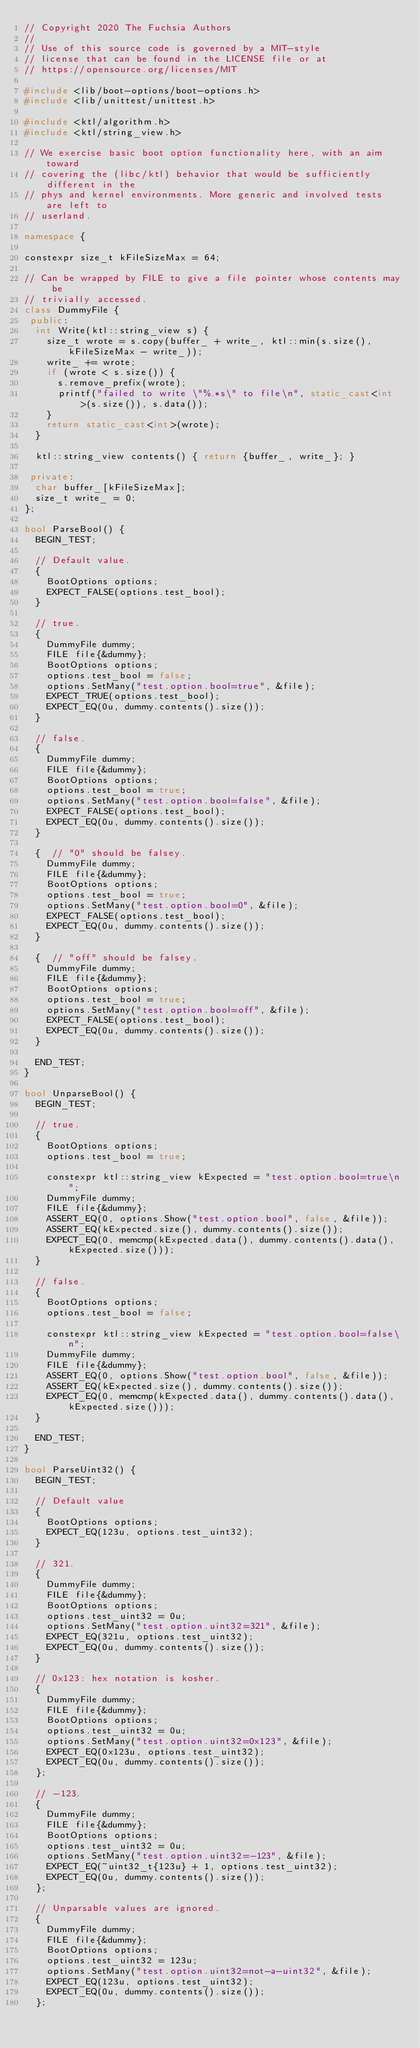Convert code to text. <code><loc_0><loc_0><loc_500><loc_500><_C++_>// Copyright 2020 The Fuchsia Authors
//
// Use of this source code is governed by a MIT-style
// license that can be found in the LICENSE file or at
// https://opensource.org/licenses/MIT

#include <lib/boot-options/boot-options.h>
#include <lib/unittest/unittest.h>

#include <ktl/algorithm.h>
#include <ktl/string_view.h>

// We exercise basic boot option functionality here, with an aim toward
// covering the (libc/ktl) behavior that would be sufficiently different in the
// phys and kernel environments. More generic and involved tests are left to
// userland.

namespace {

constexpr size_t kFileSizeMax = 64;

// Can be wrapped by FILE to give a file pointer whose contents may be
// trivially accessed.
class DummyFile {
 public:
  int Write(ktl::string_view s) {
    size_t wrote = s.copy(buffer_ + write_, ktl::min(s.size(), kFileSizeMax - write_));
    write_ += wrote;
    if (wrote < s.size()) {
      s.remove_prefix(wrote);
      printf("failed to write \"%.*s\" to file\n", static_cast<int>(s.size()), s.data());
    }
    return static_cast<int>(wrote);
  }

  ktl::string_view contents() { return {buffer_, write_}; }

 private:
  char buffer_[kFileSizeMax];
  size_t write_ = 0;
};

bool ParseBool() {
  BEGIN_TEST;

  // Default value.
  {
    BootOptions options;
    EXPECT_FALSE(options.test_bool);
  }

  // true.
  {
    DummyFile dummy;
    FILE file{&dummy};
    BootOptions options;
    options.test_bool = false;
    options.SetMany("test.option.bool=true", &file);
    EXPECT_TRUE(options.test_bool);
    EXPECT_EQ(0u, dummy.contents().size());
  }

  // false.
  {
    DummyFile dummy;
    FILE file{&dummy};
    BootOptions options;
    options.test_bool = true;
    options.SetMany("test.option.bool=false", &file);
    EXPECT_FALSE(options.test_bool);
    EXPECT_EQ(0u, dummy.contents().size());
  }

  {  // "0" should be falsey.
    DummyFile dummy;
    FILE file{&dummy};
    BootOptions options;
    options.test_bool = true;
    options.SetMany("test.option.bool=0", &file);
    EXPECT_FALSE(options.test_bool);
    EXPECT_EQ(0u, dummy.contents().size());
  }

  {  // "off" should be falsey.
    DummyFile dummy;
    FILE file{&dummy};
    BootOptions options;
    options.test_bool = true;
    options.SetMany("test.option.bool=off", &file);
    EXPECT_FALSE(options.test_bool);
    EXPECT_EQ(0u, dummy.contents().size());
  }

  END_TEST;
}

bool UnparseBool() {
  BEGIN_TEST;

  // true.
  {
    BootOptions options;
    options.test_bool = true;

    constexpr ktl::string_view kExpected = "test.option.bool=true\n";
    DummyFile dummy;
    FILE file{&dummy};
    ASSERT_EQ(0, options.Show("test.option.bool", false, &file));
    ASSERT_EQ(kExpected.size(), dummy.contents().size());
    EXPECT_EQ(0, memcmp(kExpected.data(), dummy.contents().data(), kExpected.size()));
  }

  // false.
  {
    BootOptions options;
    options.test_bool = false;

    constexpr ktl::string_view kExpected = "test.option.bool=false\n";
    DummyFile dummy;
    FILE file{&dummy};
    ASSERT_EQ(0, options.Show("test.option.bool", false, &file));
    ASSERT_EQ(kExpected.size(), dummy.contents().size());
    EXPECT_EQ(0, memcmp(kExpected.data(), dummy.contents().data(), kExpected.size()));
  }

  END_TEST;
}

bool ParseUint32() {
  BEGIN_TEST;

  // Default value
  {
    BootOptions options;
    EXPECT_EQ(123u, options.test_uint32);
  }

  // 321.
  {
    DummyFile dummy;
    FILE file{&dummy};
    BootOptions options;
    options.test_uint32 = 0u;
    options.SetMany("test.option.uint32=321", &file);
    EXPECT_EQ(321u, options.test_uint32);
    EXPECT_EQ(0u, dummy.contents().size());
  }

  // 0x123: hex notation is kosher.
  {
    DummyFile dummy;
    FILE file{&dummy};
    BootOptions options;
    options.test_uint32 = 0u;
    options.SetMany("test.option.uint32=0x123", &file);
    EXPECT_EQ(0x123u, options.test_uint32);
    EXPECT_EQ(0u, dummy.contents().size());
  };

  // -123.
  {
    DummyFile dummy;
    FILE file{&dummy};
    BootOptions options;
    options.test_uint32 = 0u;
    options.SetMany("test.option.uint32=-123", &file);
    EXPECT_EQ(~uint32_t{123u} + 1, options.test_uint32);
    EXPECT_EQ(0u, dummy.contents().size());
  };

  // Unparsable values are ignored.
  {
    DummyFile dummy;
    FILE file{&dummy};
    BootOptions options;
    options.test_uint32 = 123u;
    options.SetMany("test.option.uint32=not-a-uint32", &file);
    EXPECT_EQ(123u, options.test_uint32);
    EXPECT_EQ(0u, dummy.contents().size());
  };
</code> 